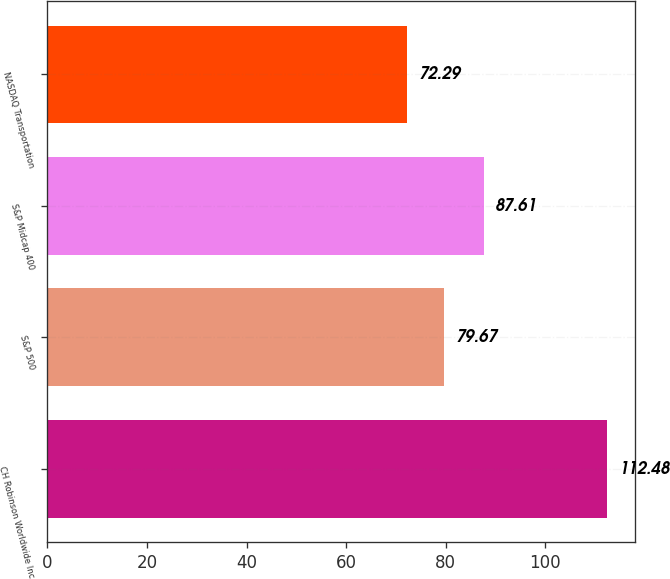Convert chart to OTSL. <chart><loc_0><loc_0><loc_500><loc_500><bar_chart><fcel>CH Robinson Worldwide Inc<fcel>S&P 500<fcel>S&P Midcap 400<fcel>NASDAQ Transportation<nl><fcel>112.48<fcel>79.67<fcel>87.61<fcel>72.29<nl></chart> 